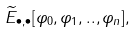Convert formula to latex. <formula><loc_0><loc_0><loc_500><loc_500>\widetilde { E } _ { \bullet , \bullet } [ \varphi _ { 0 } , \varphi _ { 1 } , . . , \varphi _ { n } ] ,</formula> 